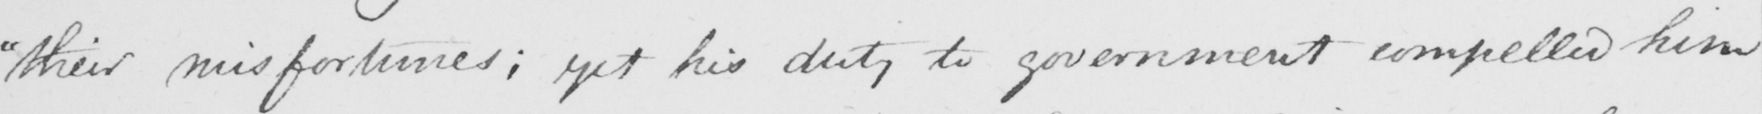Please transcribe the handwritten text in this image. " their misfortunes , yet his duty to government compelled him 